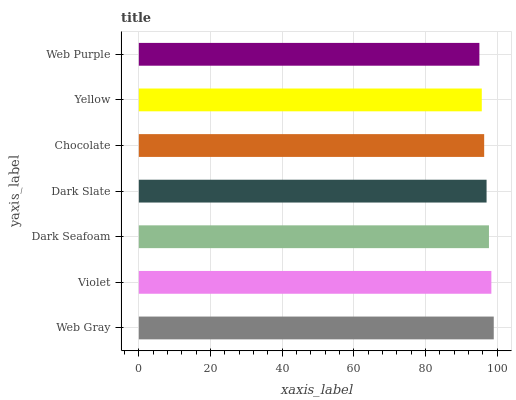Is Web Purple the minimum?
Answer yes or no. Yes. Is Web Gray the maximum?
Answer yes or no. Yes. Is Violet the minimum?
Answer yes or no. No. Is Violet the maximum?
Answer yes or no. No. Is Web Gray greater than Violet?
Answer yes or no. Yes. Is Violet less than Web Gray?
Answer yes or no. Yes. Is Violet greater than Web Gray?
Answer yes or no. No. Is Web Gray less than Violet?
Answer yes or no. No. Is Dark Slate the high median?
Answer yes or no. Yes. Is Dark Slate the low median?
Answer yes or no. Yes. Is Web Gray the high median?
Answer yes or no. No. Is Web Gray the low median?
Answer yes or no. No. 